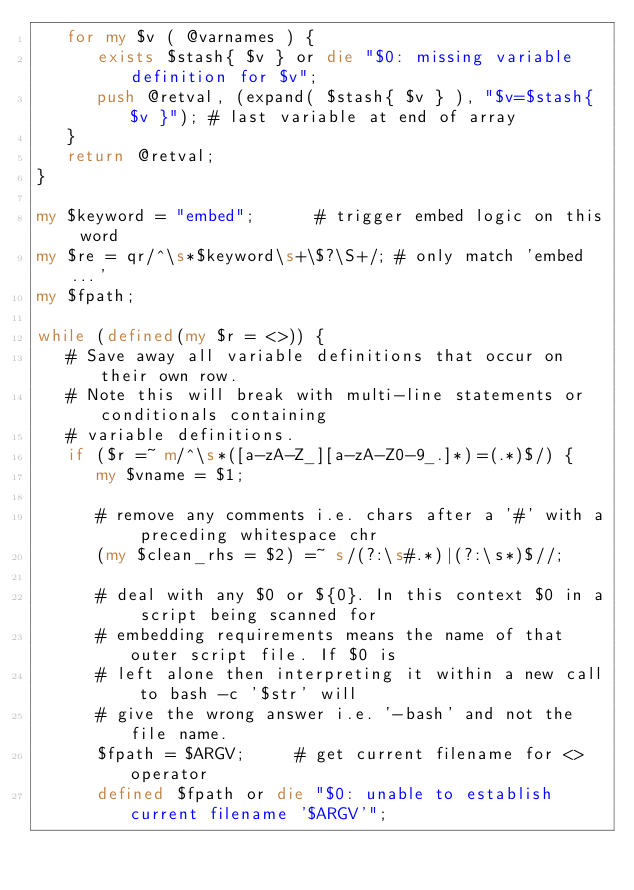<code> <loc_0><loc_0><loc_500><loc_500><_Perl_>   for my $v ( @varnames ) {
      exists $stash{ $v } or die "$0: missing variable definition for $v";
      push @retval, (expand( $stash{ $v } ), "$v=$stash{ $v }"); # last variable at end of array
   }
   return @retval;
}

my $keyword = "embed";			# trigger embed logic on this word
my $re = qr/^\s*$keyword\s+\$?\S+/;	# only match 'embed...'
my $fpath;

while (defined(my $r = <>)) {
   # Save away all variable definitions that occur on their own row. 
   # Note this will break with multi-line statements or conditionals containing
   # variable definitions.
   if ($r =~ m/^\s*([a-zA-Z_][a-zA-Z0-9_.]*)=(.*)$/) {	
      my $vname = $1;

      # remove any comments i.e. chars after a '#' with a preceding whitespace chr
      (my $clean_rhs = $2) =~ s/(?:\s#.*)|(?:\s*)$//; 

      # deal with any $0 or ${0}. In this context $0 in a script being scanned for
      # embedding requirements means the name of that outer script file. If $0 is 
      # left alone then interpreting it within a new call to bash -c '$str' will
      # give the wrong answer i.e. '-bash' and not the file name.
      $fpath = $ARGV;			# get current filename for <> operator
      defined $fpath or die "$0: unable to establish current filename '$ARGV'";</code> 